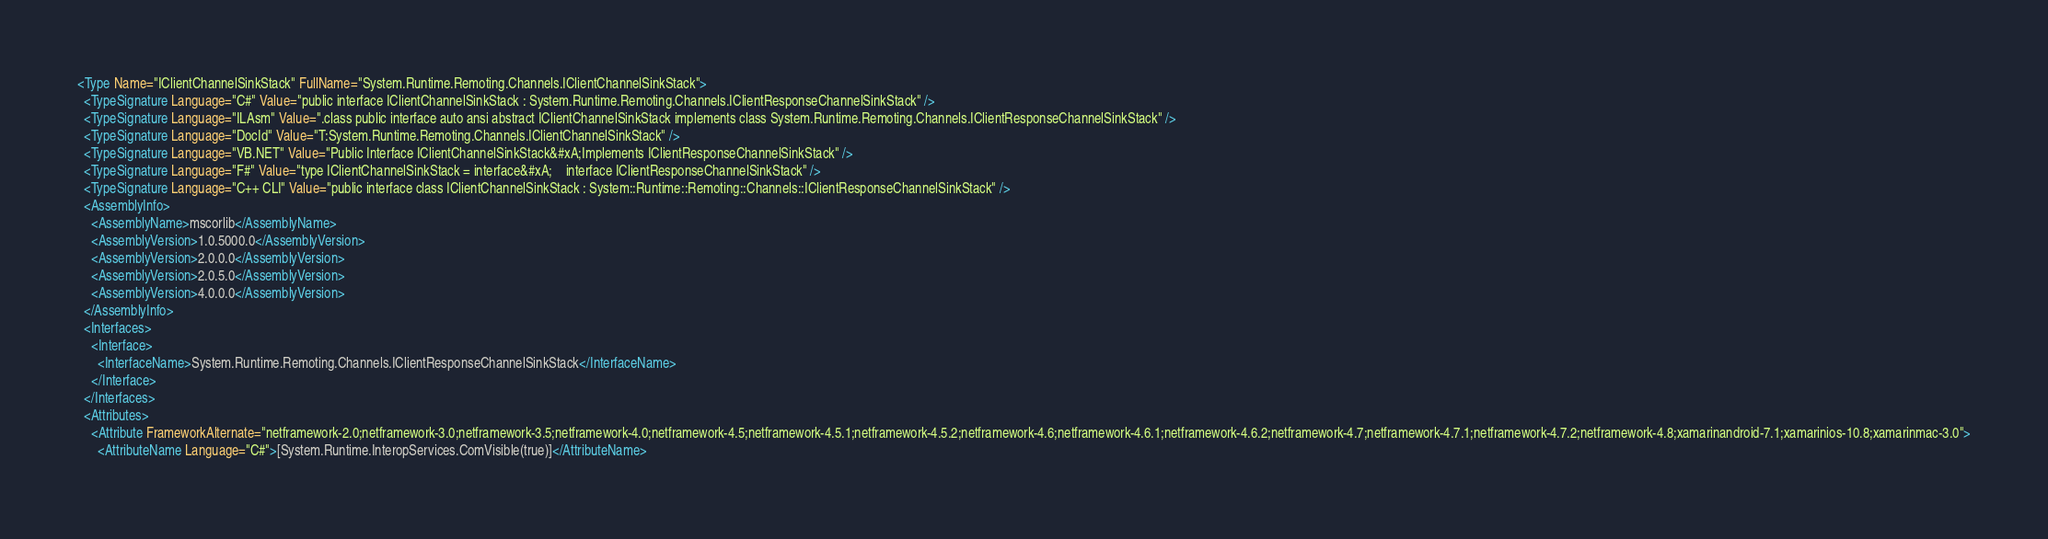<code> <loc_0><loc_0><loc_500><loc_500><_XML_><Type Name="IClientChannelSinkStack" FullName="System.Runtime.Remoting.Channels.IClientChannelSinkStack">
  <TypeSignature Language="C#" Value="public interface IClientChannelSinkStack : System.Runtime.Remoting.Channels.IClientResponseChannelSinkStack" />
  <TypeSignature Language="ILAsm" Value=".class public interface auto ansi abstract IClientChannelSinkStack implements class System.Runtime.Remoting.Channels.IClientResponseChannelSinkStack" />
  <TypeSignature Language="DocId" Value="T:System.Runtime.Remoting.Channels.IClientChannelSinkStack" />
  <TypeSignature Language="VB.NET" Value="Public Interface IClientChannelSinkStack&#xA;Implements IClientResponseChannelSinkStack" />
  <TypeSignature Language="F#" Value="type IClientChannelSinkStack = interface&#xA;    interface IClientResponseChannelSinkStack" />
  <TypeSignature Language="C++ CLI" Value="public interface class IClientChannelSinkStack : System::Runtime::Remoting::Channels::IClientResponseChannelSinkStack" />
  <AssemblyInfo>
    <AssemblyName>mscorlib</AssemblyName>
    <AssemblyVersion>1.0.5000.0</AssemblyVersion>
    <AssemblyVersion>2.0.0.0</AssemblyVersion>
    <AssemblyVersion>2.0.5.0</AssemblyVersion>
    <AssemblyVersion>4.0.0.0</AssemblyVersion>
  </AssemblyInfo>
  <Interfaces>
    <Interface>
      <InterfaceName>System.Runtime.Remoting.Channels.IClientResponseChannelSinkStack</InterfaceName>
    </Interface>
  </Interfaces>
  <Attributes>
    <Attribute FrameworkAlternate="netframework-2.0;netframework-3.0;netframework-3.5;netframework-4.0;netframework-4.5;netframework-4.5.1;netframework-4.5.2;netframework-4.6;netframework-4.6.1;netframework-4.6.2;netframework-4.7;netframework-4.7.1;netframework-4.7.2;netframework-4.8;xamarinandroid-7.1;xamarinios-10.8;xamarinmac-3.0">
      <AttributeName Language="C#">[System.Runtime.InteropServices.ComVisible(true)]</AttributeName></code> 